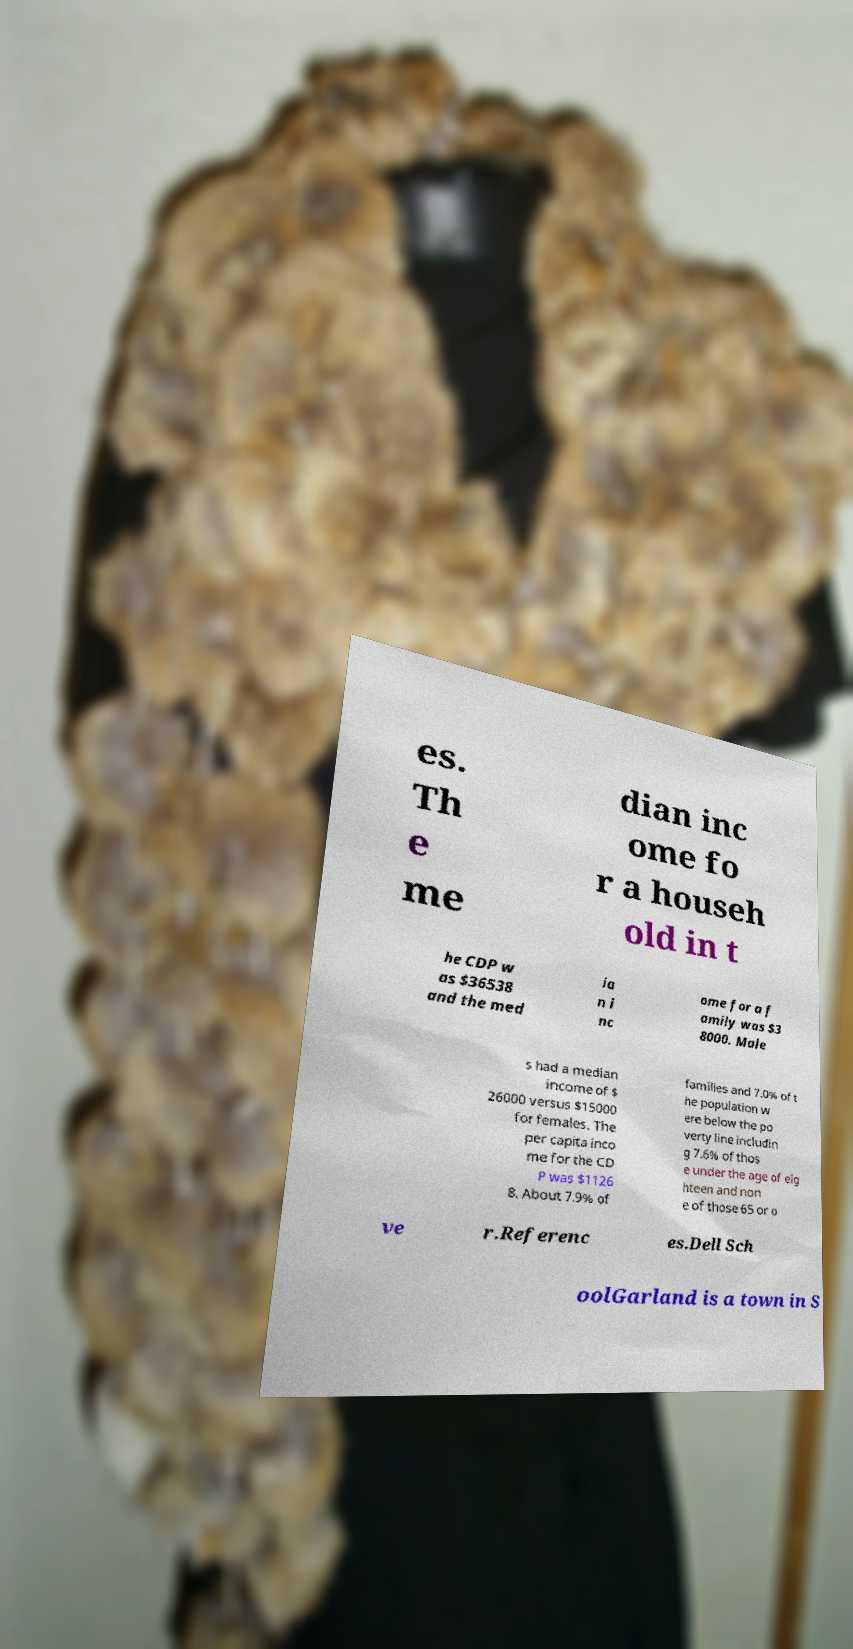There's text embedded in this image that I need extracted. Can you transcribe it verbatim? es. Th e me dian inc ome fo r a househ old in t he CDP w as $36538 and the med ia n i nc ome for a f amily was $3 8000. Male s had a median income of $ 26000 versus $15000 for females. The per capita inco me for the CD P was $1126 8. About 7.9% of families and 7.0% of t he population w ere below the po verty line includin g 7.6% of thos e under the age of eig hteen and non e of those 65 or o ve r.Referenc es.Dell Sch oolGarland is a town in S 